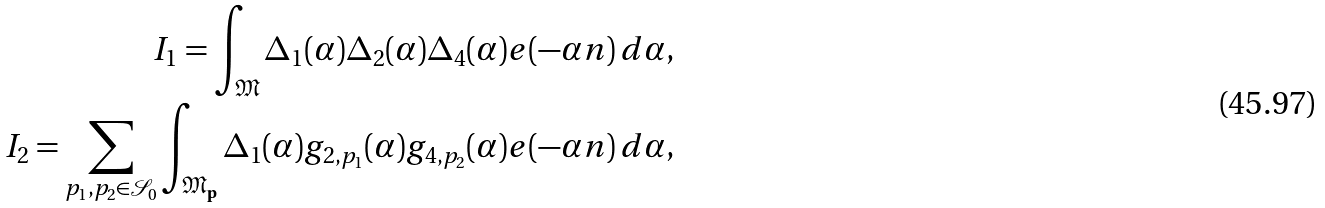<formula> <loc_0><loc_0><loc_500><loc_500>I _ { 1 } = \int _ { \mathfrak M } \Delta _ { 1 } ( \alpha ) \Delta _ { 2 } ( \alpha ) \Delta _ { 4 } ( \alpha ) e ( - \alpha n ) \, d \alpha , \\ I _ { 2 } = \sum _ { p _ { 1 } , p _ { 2 } \in \mathcal { S } _ { 0 } } \int _ { \mathfrak M _ { \mathbf p } } \Delta _ { 1 } ( \alpha ) g _ { 2 , p _ { 1 } } ( \alpha ) g _ { 4 , p _ { 2 } } ( \alpha ) e ( - \alpha n ) \, d \alpha ,</formula> 